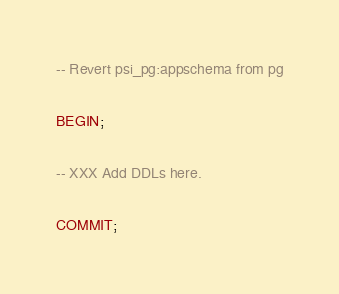<code> <loc_0><loc_0><loc_500><loc_500><_SQL_>-- Revert psi_pg:appschema from pg

BEGIN;

-- XXX Add DDLs here.

COMMIT;
</code> 